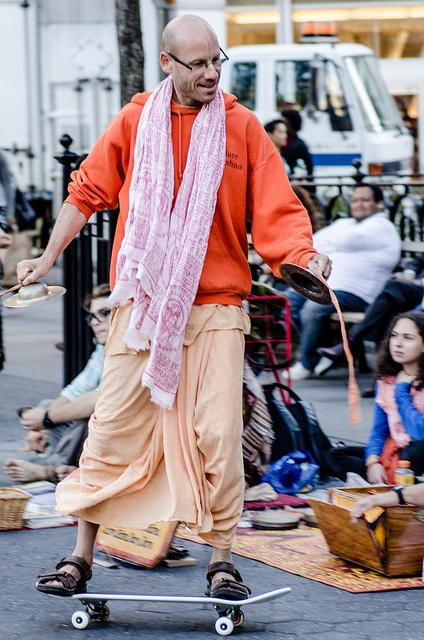In what year was his organization founded in New York City? Please explain your reasoning. 1966. The organization is from 1966. 